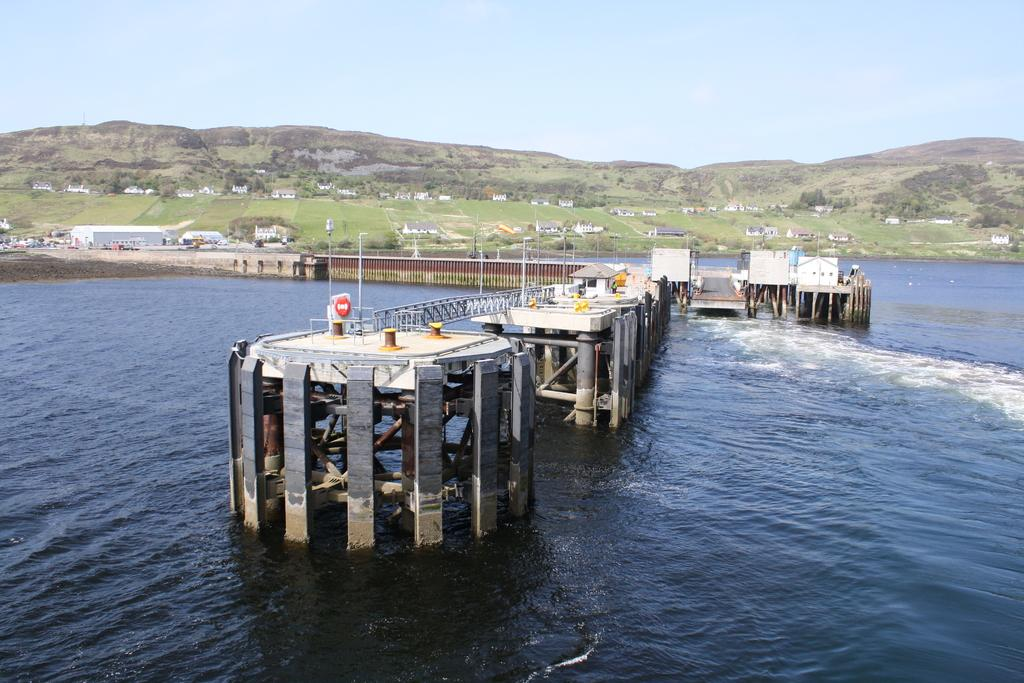What is the main structure in the water in the image? There is a bridge in the water in the image. What can be seen in the background of the image? Houses, trees, grass, mountains, and the sky are visible in the background of the image. What type of soda is being served in the yard in the image? There is no yard or soda present in the image. How does the heat affect the bridge in the image? The image does not provide information about the temperature or heat, so it cannot be determined how it affects the bridge. 